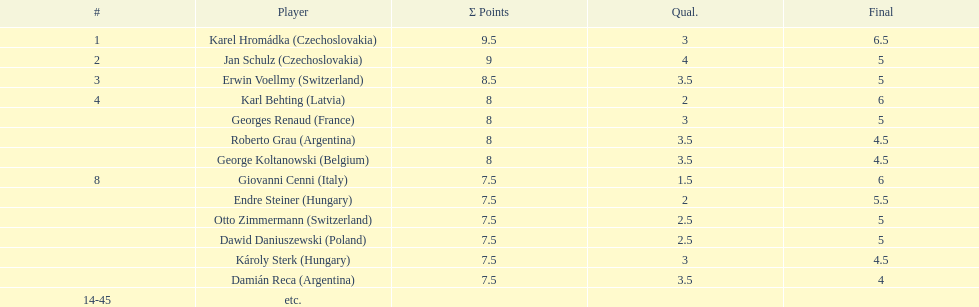Which player had the largest number of &#931; points? Karel Hromádka. 